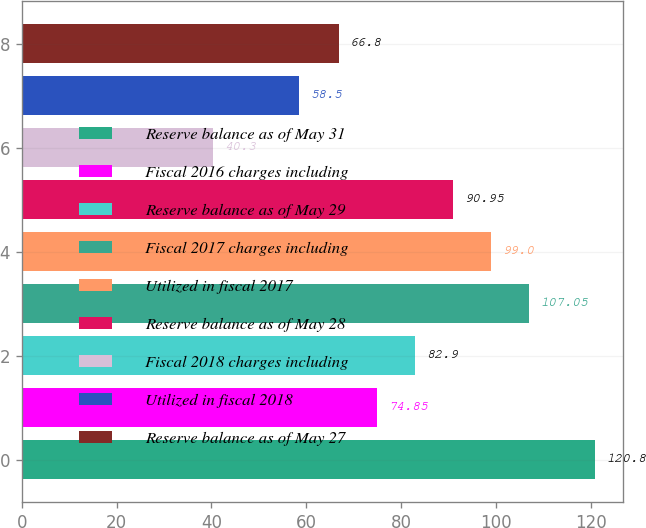Convert chart. <chart><loc_0><loc_0><loc_500><loc_500><bar_chart><fcel>Reserve balance as of May 31<fcel>Fiscal 2016 charges including<fcel>Reserve balance as of May 29<fcel>Fiscal 2017 charges including<fcel>Utilized in fiscal 2017<fcel>Reserve balance as of May 28<fcel>Fiscal 2018 charges including<fcel>Utilized in fiscal 2018<fcel>Reserve balance as of May 27<nl><fcel>120.8<fcel>74.85<fcel>82.9<fcel>107.05<fcel>99<fcel>90.95<fcel>40.3<fcel>58.5<fcel>66.8<nl></chart> 